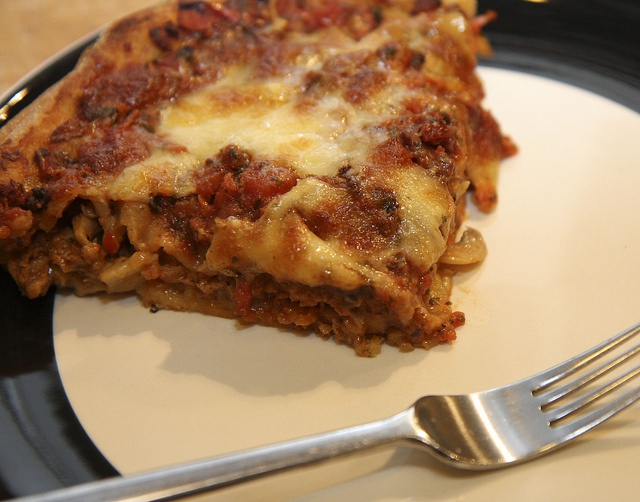Describe the objects in this image and their specific colors. I can see pizza in tan, brown, maroon, and black tones and fork in tan, darkgray, lightgray, maroon, and gray tones in this image. 